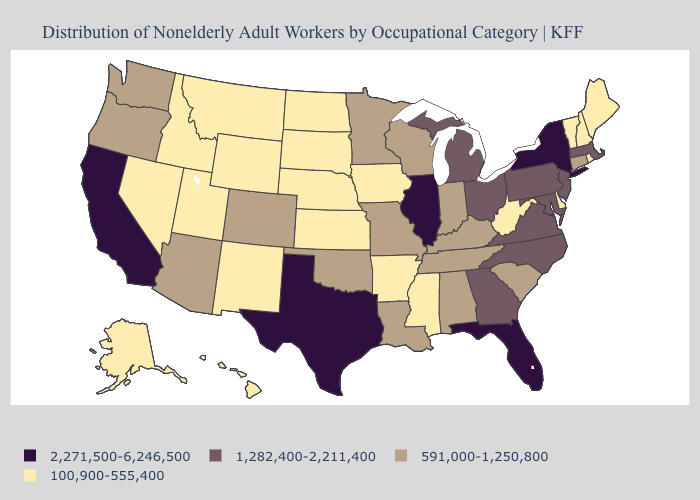Among the states that border Florida , does Alabama have the highest value?
Short answer required. No. What is the value of Kentucky?
Keep it brief. 591,000-1,250,800. Which states have the lowest value in the USA?
Be succinct. Alaska, Arkansas, Delaware, Hawaii, Idaho, Iowa, Kansas, Maine, Mississippi, Montana, Nebraska, Nevada, New Hampshire, New Mexico, North Dakota, Rhode Island, South Dakota, Utah, Vermont, West Virginia, Wyoming. What is the value of Alaska?
Answer briefly. 100,900-555,400. What is the value of Mississippi?
Be succinct. 100,900-555,400. What is the highest value in the West ?
Keep it brief. 2,271,500-6,246,500. Among the states that border Michigan , does Wisconsin have the highest value?
Be succinct. No. What is the value of New Jersey?
Short answer required. 1,282,400-2,211,400. Does Georgia have the lowest value in the USA?
Give a very brief answer. No. Name the states that have a value in the range 591,000-1,250,800?
Give a very brief answer. Alabama, Arizona, Colorado, Connecticut, Indiana, Kentucky, Louisiana, Minnesota, Missouri, Oklahoma, Oregon, South Carolina, Tennessee, Washington, Wisconsin. What is the value of Vermont?
Concise answer only. 100,900-555,400. Does the map have missing data?
Quick response, please. No. Name the states that have a value in the range 100,900-555,400?
Short answer required. Alaska, Arkansas, Delaware, Hawaii, Idaho, Iowa, Kansas, Maine, Mississippi, Montana, Nebraska, Nevada, New Hampshire, New Mexico, North Dakota, Rhode Island, South Dakota, Utah, Vermont, West Virginia, Wyoming. What is the highest value in the South ?
Quick response, please. 2,271,500-6,246,500. What is the value of Florida?
Write a very short answer. 2,271,500-6,246,500. 